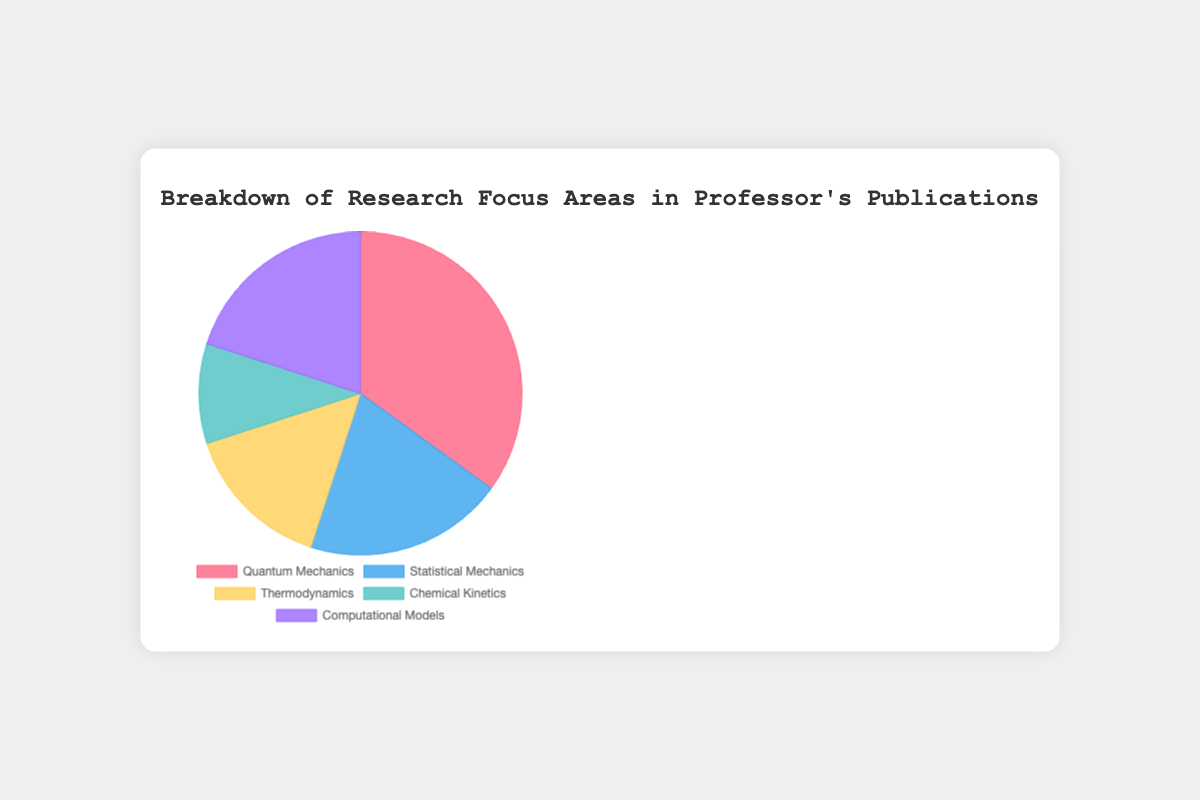What proportion of the publications focus on Quantum Mechanics? The figure shows that there are 35 publications on Quantum Mechanics out of a total of 100 publications. The proportion is calculated as 35/100, which is 0.35 or 35%.
Answer: 35% Which research area has the fewest publications? The figure indicates that Chemical Kinetics has the fewest publications with 10 publications.
Answer: Chemical Kinetics What is the combined number of publications in Statistical Mechanics and Computational Models? According to the figure, Statistical Mechanics has 20 publications and Computational Models also have 20 publications. Adding these together gives 20 + 20 = 40.
Answer: 40 How does the number of publications in Thermodynamics compare to Statistical Mechanics? The figure shows 15 publications in Thermodynamics and 20 publications in Statistical Mechanics. Thermodynamics has 5 fewer publications than Statistical Mechanics.
Answer: 5 fewer What percentage of the publications focus on areas other than Quantum Mechanics? Quantum Mechanics has 35 publications out of a total of 100. Therefore, publications in other areas account for (100 - 35) = 65 publications. The percentage is 65/100 = 65%.
Answer: 65% If the professor were to publish 5 more papers in Computational Models, what would be the new total number of publications in that area? The current number of publications in Computational Models is 20. Adding 5 more would result in 20 + 5 = 25 publications.
Answer: 25 Which color corresponds to Chemical Kinetics in the pie chart? Chemical Kinetics is represented by light blue color in the pie chart.
Answer: light blue What is the total number of publications represented in the chart? By adding up the number of publications in each area (35 for Quantum Mechanics, 20 for Statistical Mechanics, 15 for Thermodynamics, 10 for Chemical Kinetics, and 20 for Computational Models), we get 35 + 20 + 15 + 10 + 20 = 100 publications.
Answer: 100 How many more publications are there in Quantum Mechanics than in Chemical Kinetics and Thermodynamics combined? Quantum Mechanics has 35 publications, while Chemical Kinetics and Thermodynamics combined have 10 + 15 = 25 publications. The difference is 35 - 25 = 10 publications.
Answer: 10 